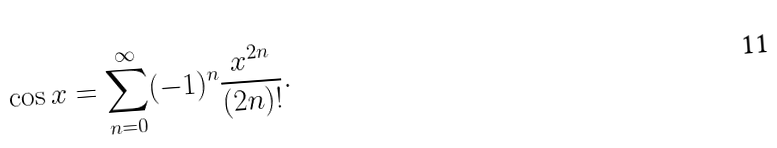Convert formula to latex. <formula><loc_0><loc_0><loc_500><loc_500>\cos x = \sum _ { n = 0 } ^ { \infty } ( - 1 ) ^ { n } { \frac { x ^ { 2 n } } { ( 2 n ) ! } } .</formula> 